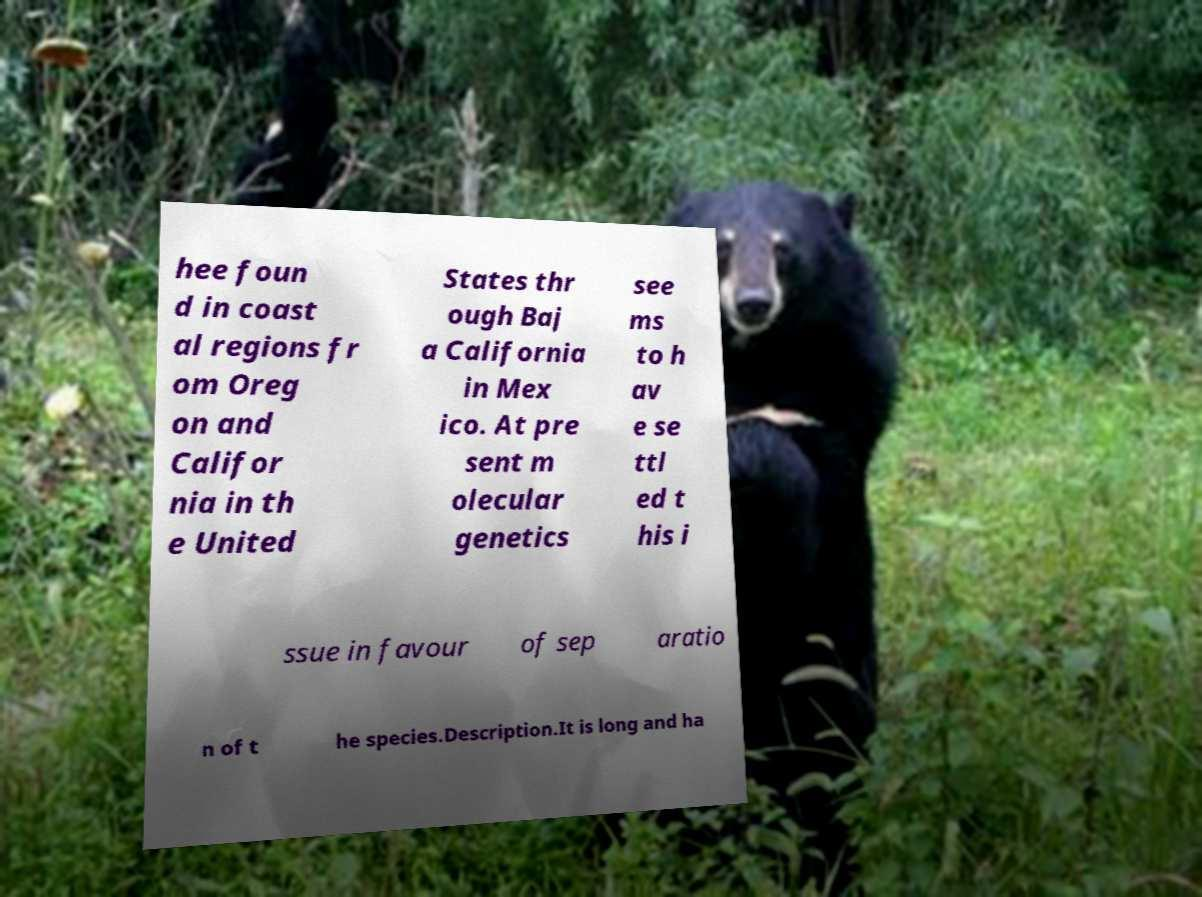There's text embedded in this image that I need extracted. Can you transcribe it verbatim? hee foun d in coast al regions fr om Oreg on and Califor nia in th e United States thr ough Baj a California in Mex ico. At pre sent m olecular genetics see ms to h av e se ttl ed t his i ssue in favour of sep aratio n of t he species.Description.It is long and ha 